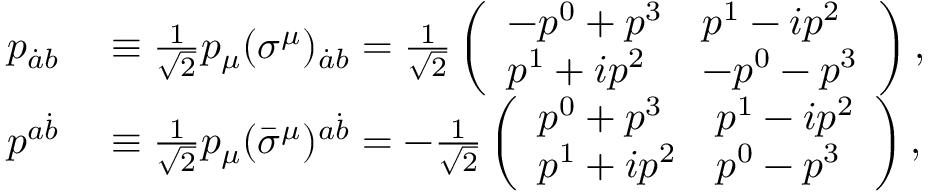<formula> <loc_0><loc_0><loc_500><loc_500>\begin{array} { r l } { p _ { \dot { a } b } } & \equiv \frac { 1 } { \sqrt { 2 } } p _ { \mu } ( \sigma ^ { \mu } ) _ { \dot { a } b } = \frac { 1 } { \sqrt { 2 } } \left ( \begin{array} { l l } { - p ^ { 0 } + p ^ { 3 } } & { p ^ { 1 } - i p ^ { 2 } } \\ { p ^ { 1 } + i p ^ { 2 } } & { - p ^ { 0 } - p ^ { 3 } } \end{array} \right ) , } \\ { p ^ { a \dot { b } } } & \equiv \frac { 1 } { \sqrt { 2 } } p _ { \mu } ( \bar { \sigma } ^ { \mu } ) ^ { a \dot { b } } = - \frac { 1 } { \sqrt { 2 } } \left ( \begin{array} { l l } { p ^ { 0 } + p ^ { 3 } } & { p ^ { 1 } - i p ^ { 2 } } \\ { p ^ { 1 } + i p ^ { 2 } } & { p ^ { 0 } - p ^ { 3 } } \end{array} \right ) , } \end{array}</formula> 